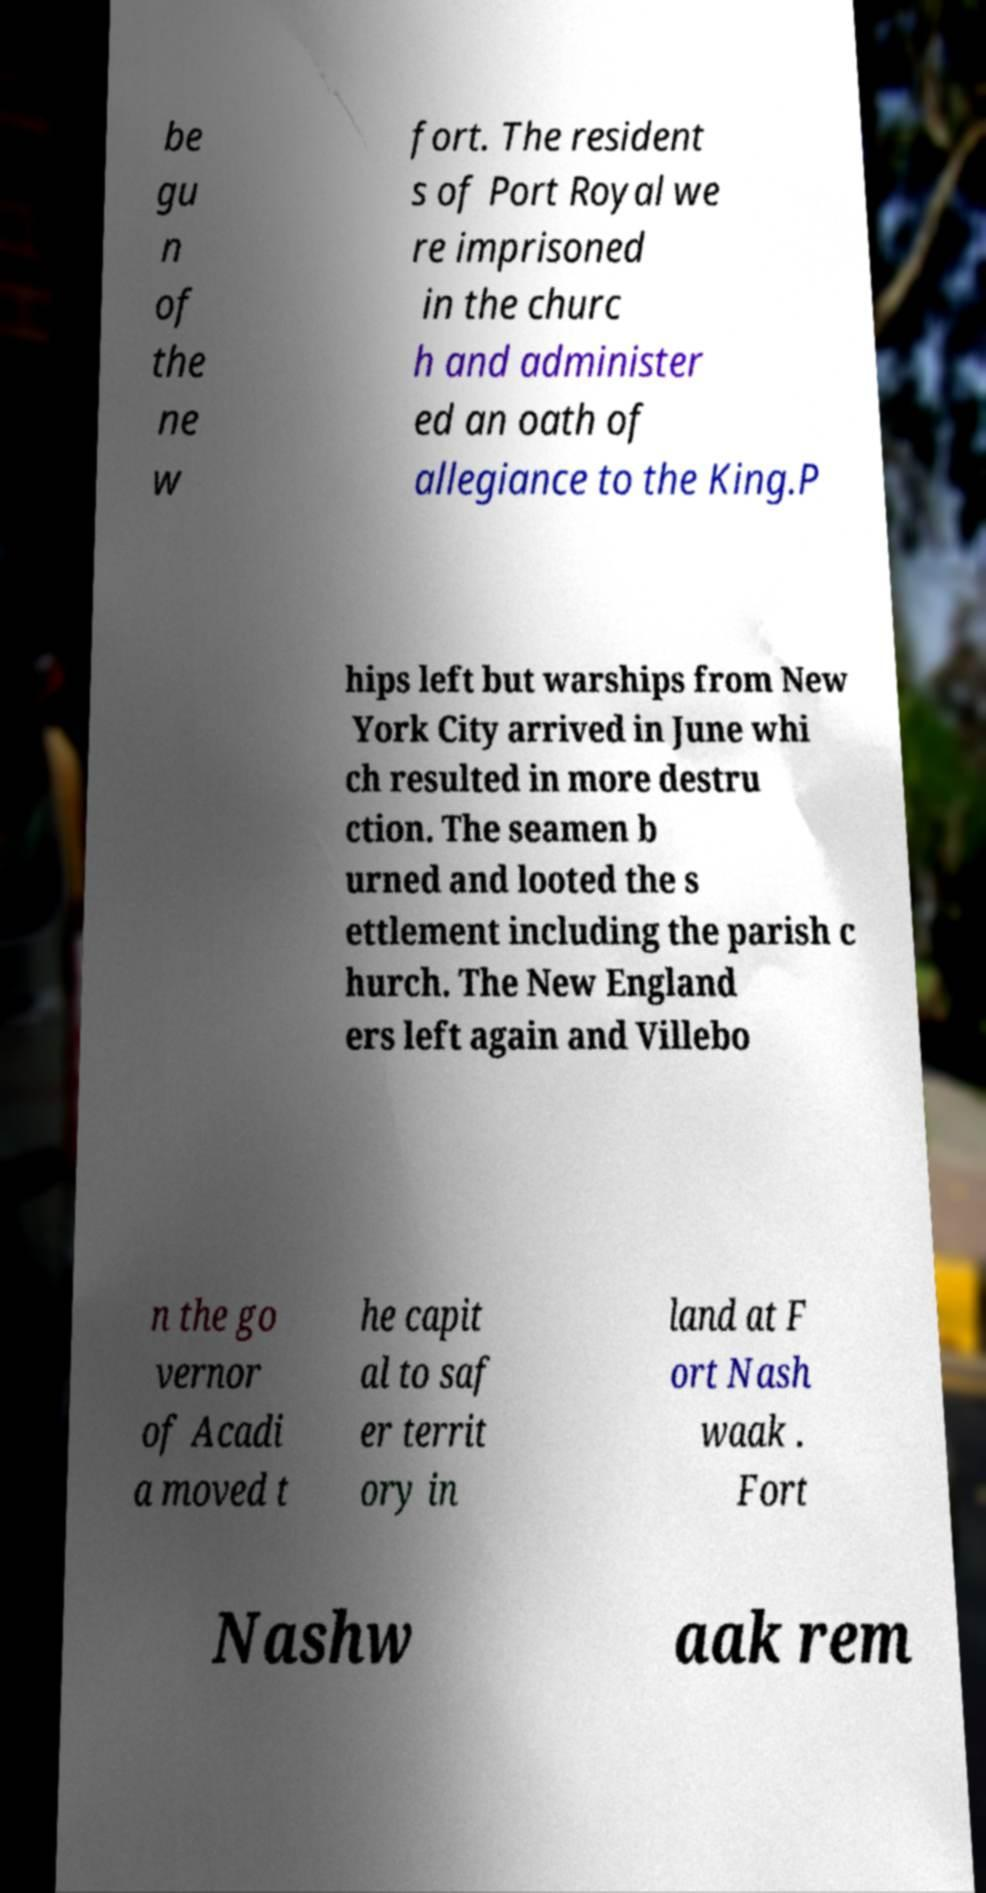Please identify and transcribe the text found in this image. be gu n of the ne w fort. The resident s of Port Royal we re imprisoned in the churc h and administer ed an oath of allegiance to the King.P hips left but warships from New York City arrived in June whi ch resulted in more destru ction. The seamen b urned and looted the s ettlement including the parish c hurch. The New England ers left again and Villebo n the go vernor of Acadi a moved t he capit al to saf er territ ory in land at F ort Nash waak . Fort Nashw aak rem 